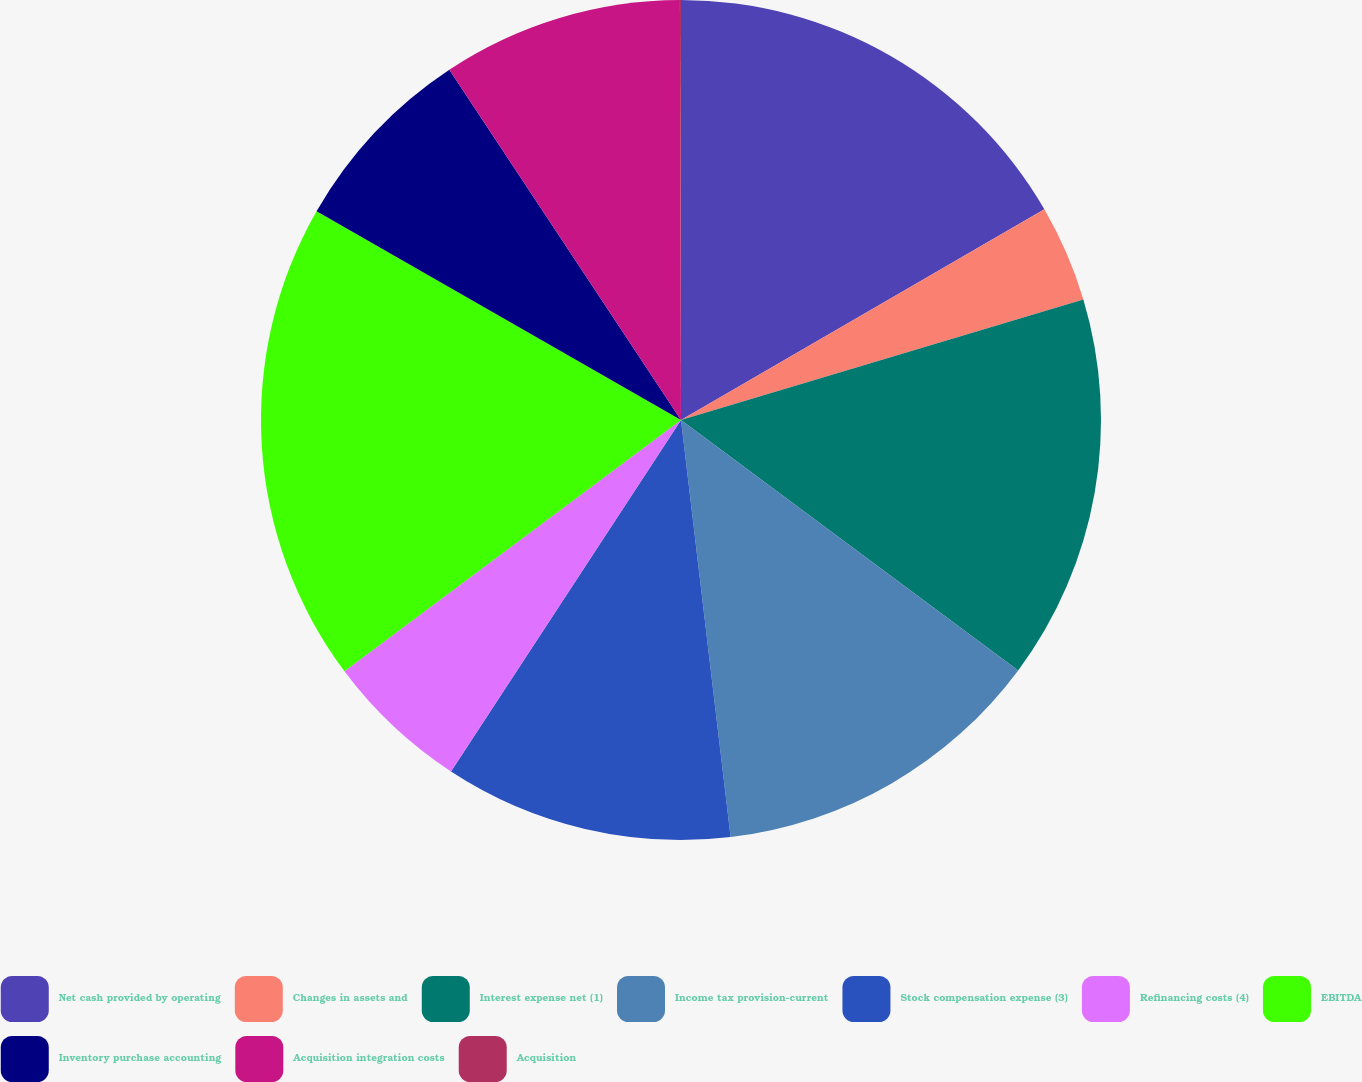Convert chart to OTSL. <chart><loc_0><loc_0><loc_500><loc_500><pie_chart><fcel>Net cash provided by operating<fcel>Changes in assets and<fcel>Interest expense net (1)<fcel>Income tax provision-current<fcel>Stock compensation expense (3)<fcel>Refinancing costs (4)<fcel>EBITDA<fcel>Inventory purchase accounting<fcel>Acquisition integration costs<fcel>Acquisition<nl><fcel>16.64%<fcel>3.73%<fcel>14.8%<fcel>12.95%<fcel>11.11%<fcel>5.57%<fcel>18.49%<fcel>7.42%<fcel>9.26%<fcel>0.04%<nl></chart> 